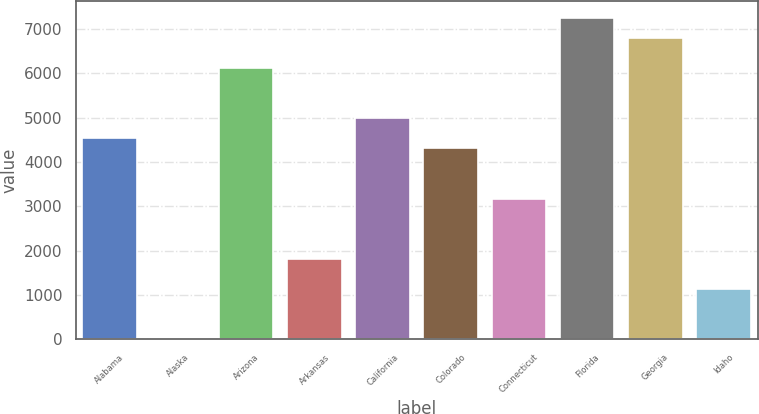<chart> <loc_0><loc_0><loc_500><loc_500><bar_chart><fcel>Alabama<fcel>Alaska<fcel>Arizona<fcel>Arkansas<fcel>California<fcel>Colorado<fcel>Connecticut<fcel>Florida<fcel>Georgia<fcel>Idaho<nl><fcel>4538<fcel>2<fcel>6125.6<fcel>1816.4<fcel>4991.6<fcel>4311.2<fcel>3177.2<fcel>7259.6<fcel>6806<fcel>1136<nl></chart> 